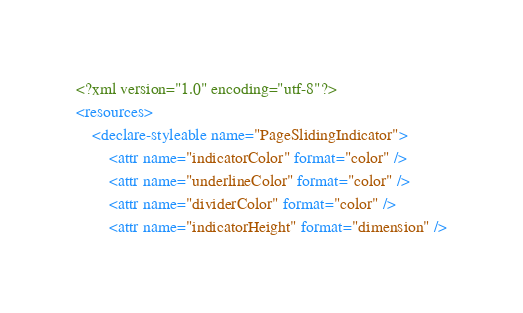Convert code to text. <code><loc_0><loc_0><loc_500><loc_500><_XML_><?xml version="1.0" encoding="utf-8"?>
<resources>
    <declare-styleable name="PageSlidingIndicator">
        <attr name="indicatorColor" format="color" />
        <attr name="underlineColor" format="color" />
        <attr name="dividerColor" format="color" />
        <attr name="indicatorHeight" format="dimension" /></code> 